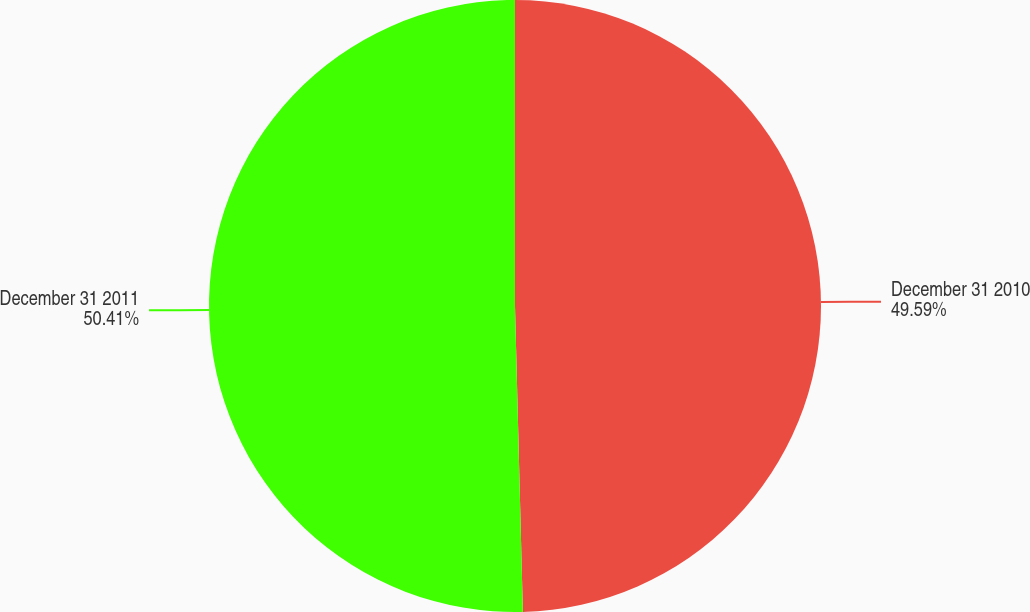Convert chart. <chart><loc_0><loc_0><loc_500><loc_500><pie_chart><fcel>December 31 2010<fcel>December 31 2011<nl><fcel>49.59%<fcel>50.41%<nl></chart> 